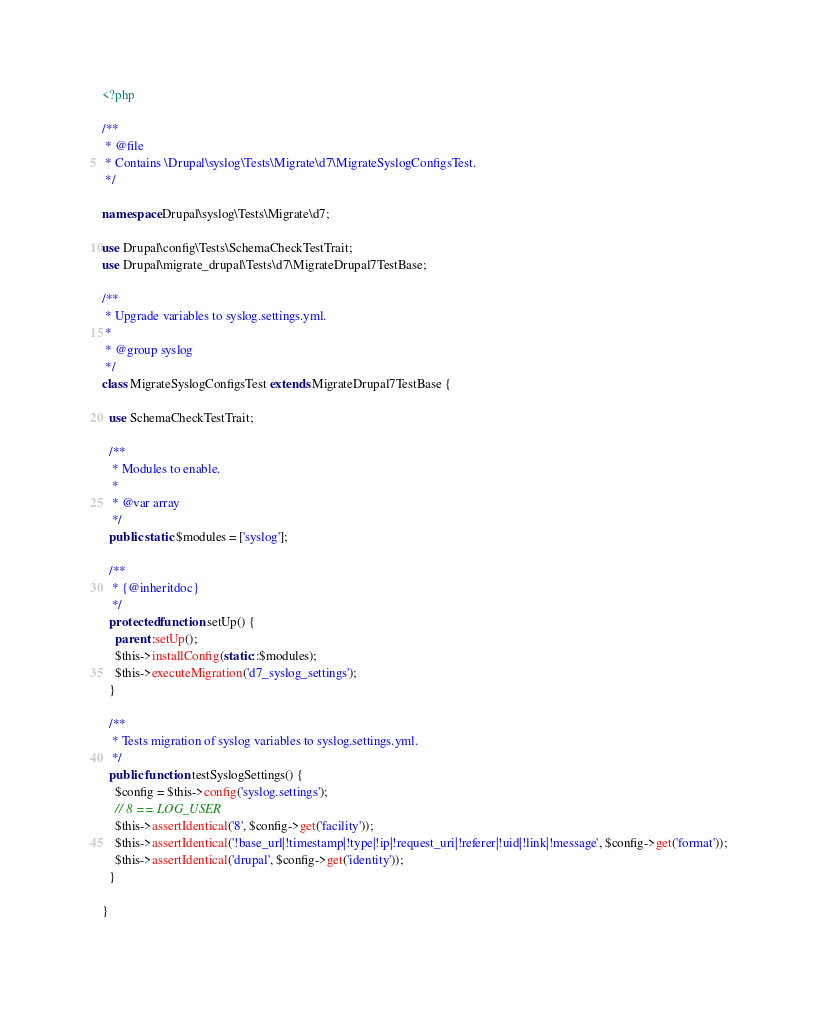Convert code to text. <code><loc_0><loc_0><loc_500><loc_500><_PHP_><?php

/**
 * @file
 * Contains \Drupal\syslog\Tests\Migrate\d7\MigrateSyslogConfigsTest.
 */

namespace Drupal\syslog\Tests\Migrate\d7;

use Drupal\config\Tests\SchemaCheckTestTrait;
use Drupal\migrate_drupal\Tests\d7\MigrateDrupal7TestBase;

/**
 * Upgrade variables to syslog.settings.yml.
 *
 * @group syslog
 */
class MigrateSyslogConfigsTest extends MigrateDrupal7TestBase {

  use SchemaCheckTestTrait;

  /**
   * Modules to enable.
   *
   * @var array
   */
  public static $modules = ['syslog'];

  /**
   * {@inheritdoc}
   */
  protected function setUp() {
    parent::setUp();
    $this->installConfig(static::$modules);
    $this->executeMigration('d7_syslog_settings');
  }

  /**
   * Tests migration of syslog variables to syslog.settings.yml.
   */
  public function testSyslogSettings() {
    $config = $this->config('syslog.settings');
    // 8 == LOG_USER
    $this->assertIdentical('8', $config->get('facility'));
    $this->assertIdentical('!base_url|!timestamp|!type|!ip|!request_uri|!referer|!uid|!link|!message', $config->get('format'));
    $this->assertIdentical('drupal', $config->get('identity'));
  }

}
</code> 